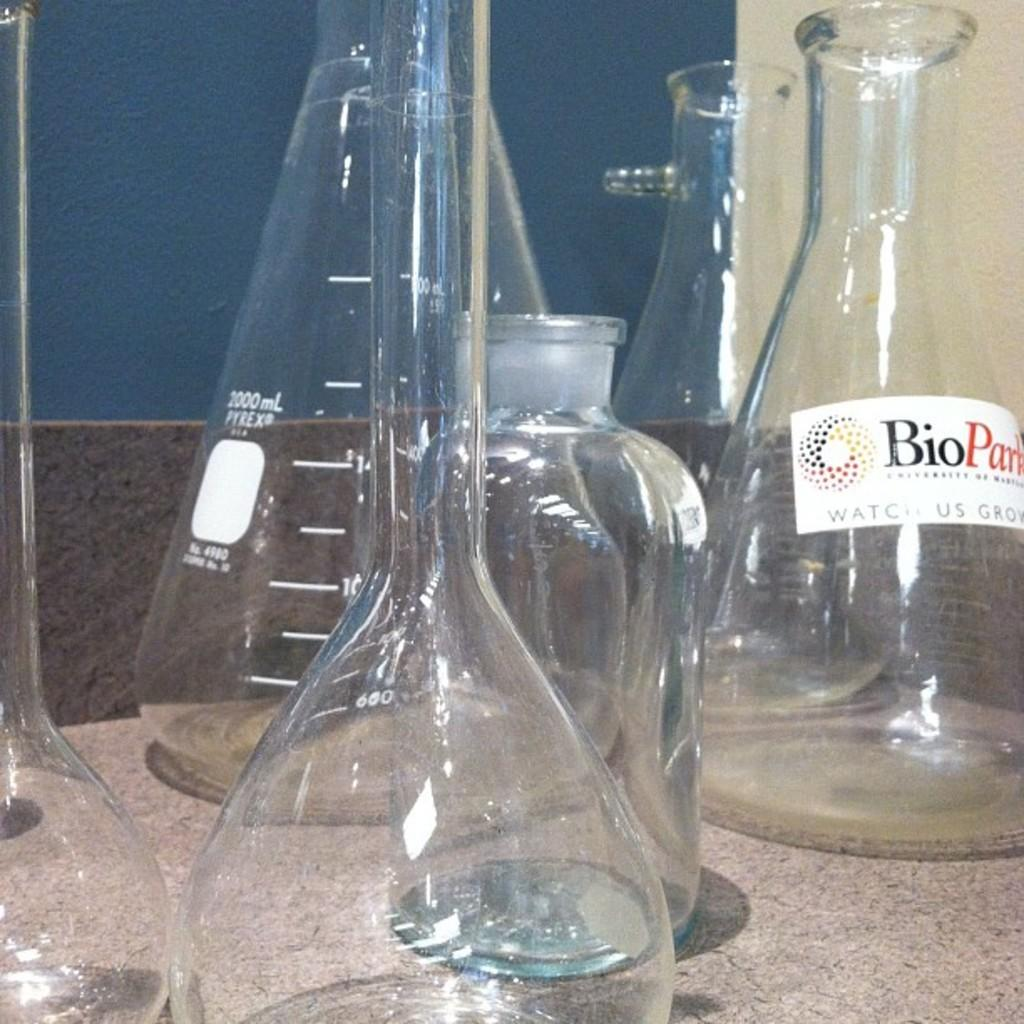<image>
Write a terse but informative summary of the picture. A collection of science beakers with BioPark printed on one. 